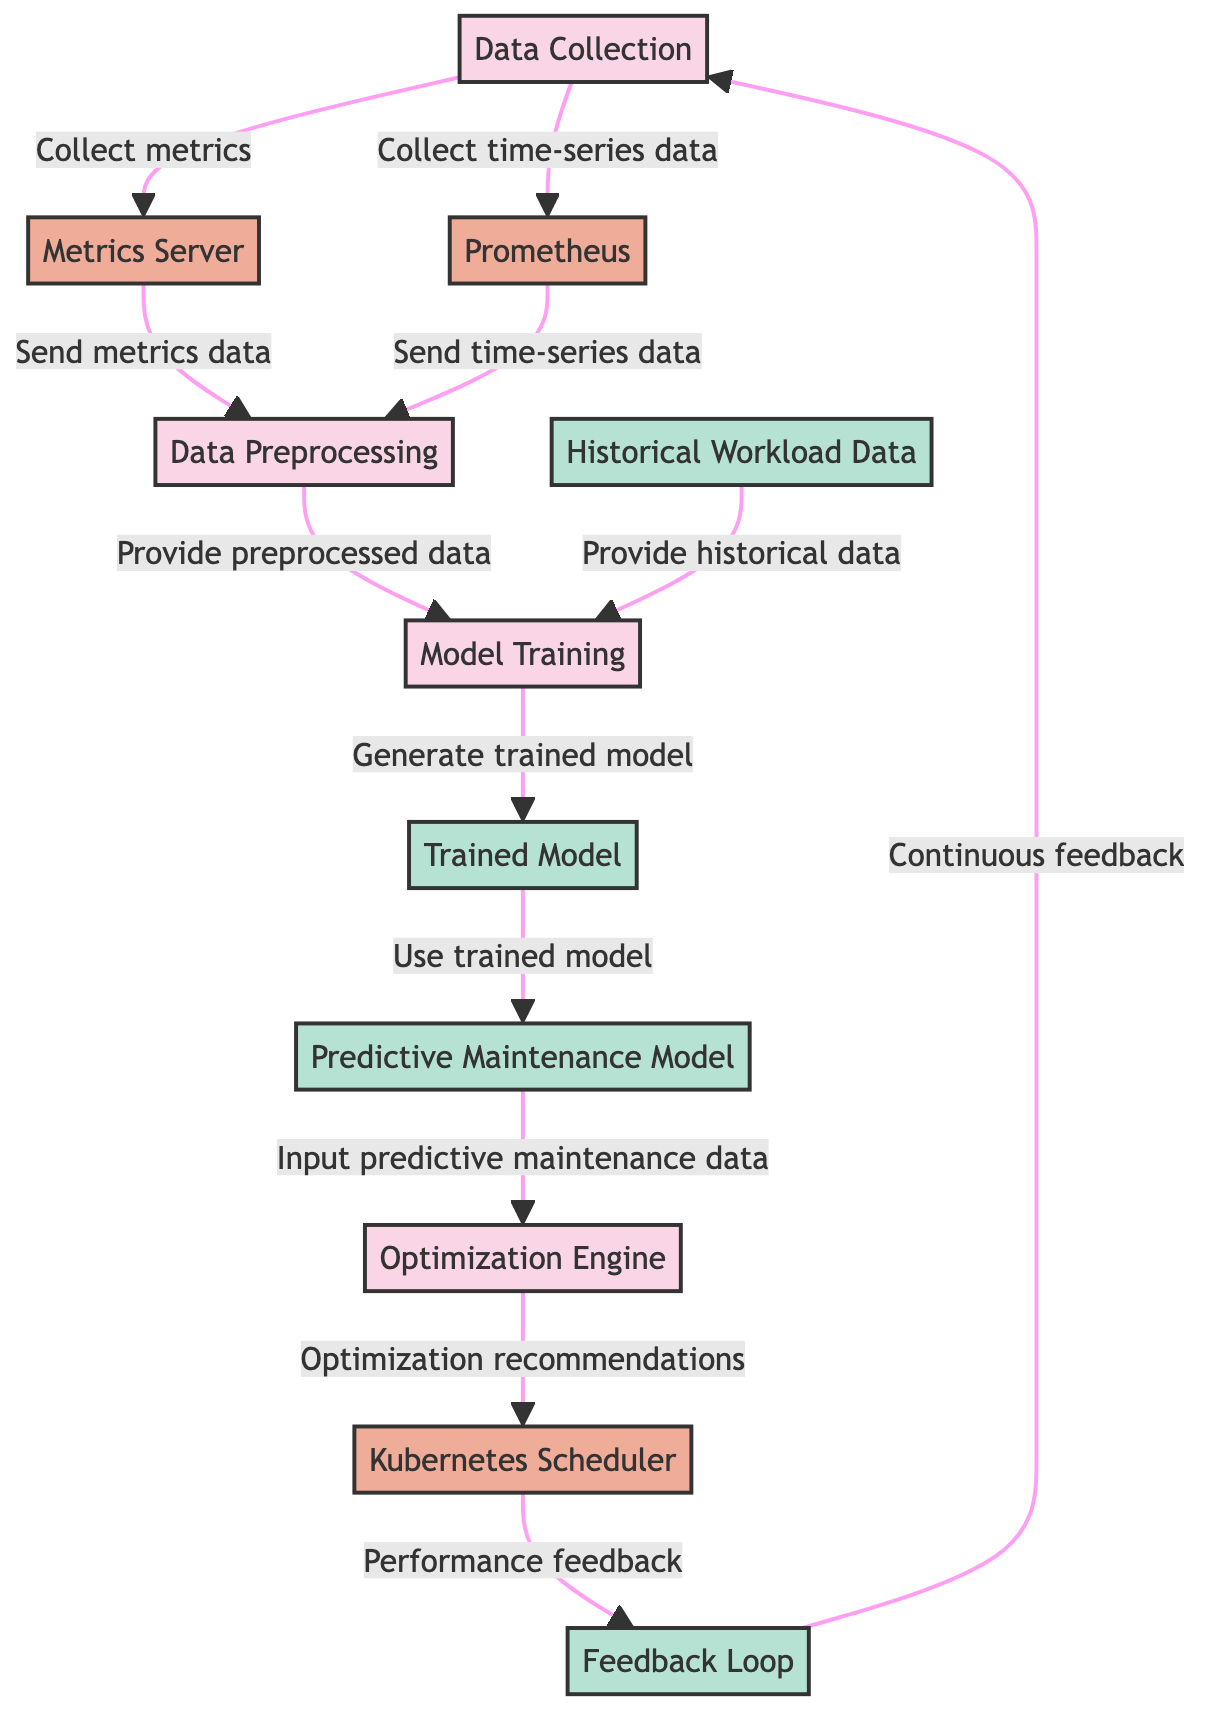What is the first step in the optimization process? The first step in the optimization process is "Data Collection," which collects metrics and time-series data from the cluster.
Answer: Data Collection How many main processes are depicted in the diagram? The diagram outlines four main processes: Data Collection, Data Preprocessing, Model Training, and Optimization Engine.
Answer: Four Which entity sends time-series data to Data Preprocessing? Prometheus is the entity that sends time-series data to the Data Preprocessing step.
Answer: Prometheus What type of data is provided to Model Training? Both historical workload data and preprocessed data are provided to Model Training.
Answer: Historical Workload Data What does the Optimization Engine output? The Optimization Engine outputs optimization recommendations to the Kubernetes Scheduler.
Answer: Optimization recommendations Which node receives feedback from the Kubernetes Scheduler? The Feedback Loop node receives performance feedback from the Kubernetes Scheduler.
Answer: Feedback Loop How does the flow of information return to Data Collection? The continuous feedback from the Feedback Loop provides insight back to Data Collection, creating a cyclical flow where performance is constantly monitored and updated.
Answer: Continous feedback What is the role of the Trained Model in this diagram? The Trained Model is used in creating the Predictive Maintenance Model by providing insights on workload patterns.
Answer: Use trained model What connects the optimization recommendations to the Kubernetes Scheduler? A directed arrow indicates that the Optimization Engine provides optimization recommendations to the Kubernetes Scheduler.
Answer: Directed arrow 